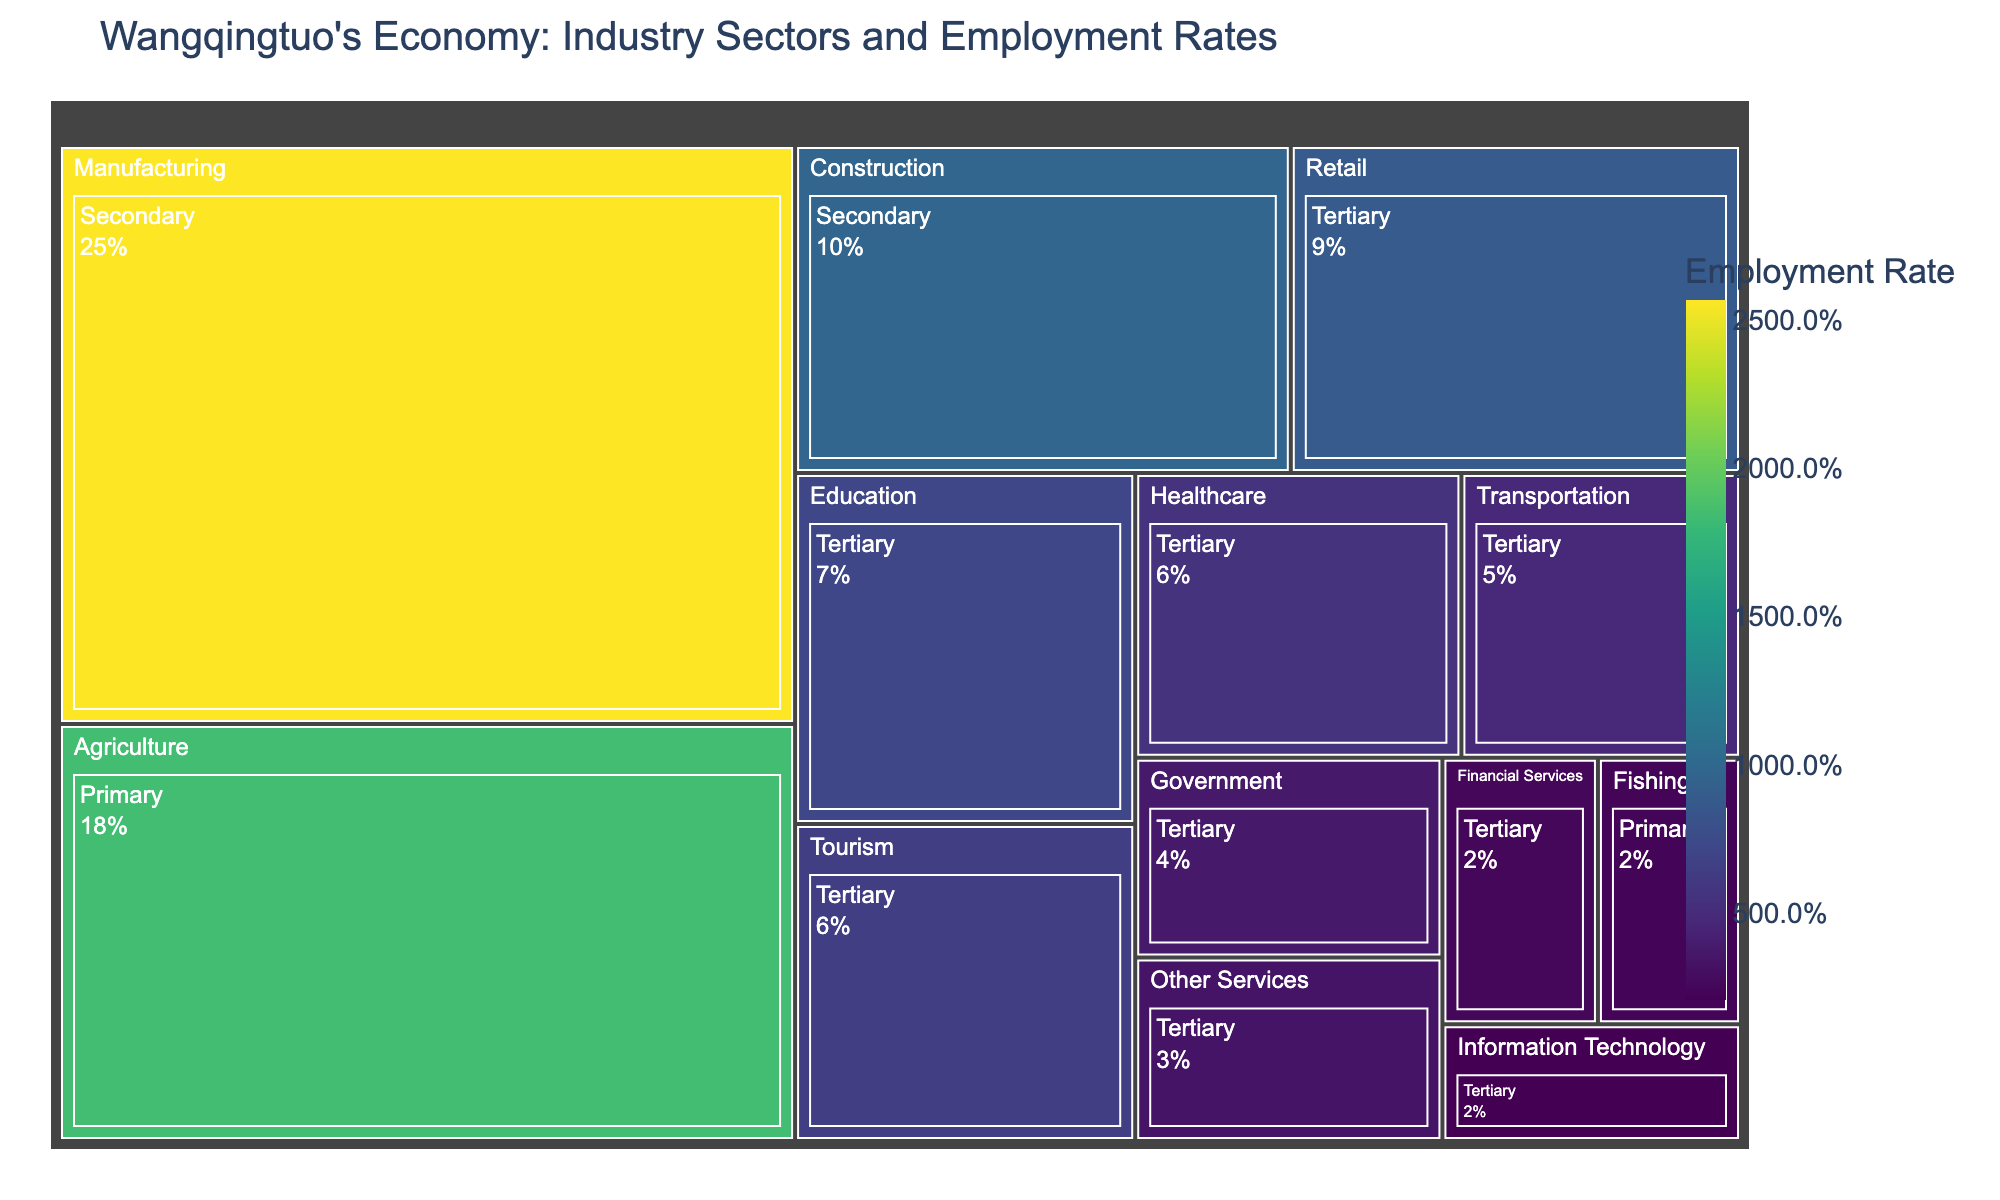What is the title of the Treemap? The title is usually located at the top of the figure and provides an overview of what the Treemap is displaying. In this case, it should indicate something about Wangqingtuo's economy in terms of industry sectors and employment rates.
Answer: Wangqingtuo's Economy: Industry Sectors and Employment Rates Which industry sector has the highest employment rate? By looking at the relative sizes of the sectors in the Treemap, the largest block corresponds to the sector with the highest employment rate.
Answer: Manufacturing How much higher is the employment rate in the Manufacturing sector compared to the Education sector? First, locate the employment rates in both sectors from the Treemap. Manufacturing has an employment rate of 25.7% and Education has 7.2%. The difference is calculated as 25.7 - 7.2.
Answer: 18.5% List all the industry sectors within the Primary category. In the Treemap, the sectors are usually grouped together. Look for the sectors labeled under Primary category.
Answer: Agriculture, Fishing What is the total employment rate for the Tertiary sector? Sum the employment rates of all the sub-sectors under Tertiary. The rates are: 7.2 (Education), 6.5 (Tourism), 8.9 (Retail), 5.6 (Healthcare), 4.8 (Transportation), 3.7 (Government), 2.5 (Financial Services), 2.1 (Information Technology), and 3.4 (Other Services). The total is 7.2+6.5+8.9+5.6+4.8+3.7+2.5+2.1+3.4.
Answer: 44.7% How does the employment rate in Agriculture compare to that in Healthcare? Locate the employment rates in both sectors from the Treemap. Agriculture has an employment rate of 18.5%, while Healthcare has 5.6%. Compare these values.
Answer: Agriculture has a higher employment rate Which sector within the Tertiary industry has the lowest employment rate, and what is it? Within the Tertiary sector, look for the smallest block or the one with the least percentage. The smallest block is Information Technology with an employment rate of 2.1%.
Answer: Information Technology, 2.1% What percentage of the Secondary sector does Construction represent? Within the Secondary sector, locate the blocks for Construction and Manufacturing, and find their employment rates. The total for the Secondary sector is 25.7 + 9.8. Construction represents 9.8 / (25.7 + 9.8) of the Secondary sector. Calculate 9.8 / 35.5 and multiply by 100.
Answer: 27.6% Which sector has a higher employment rate: Tourism or Government? Locate the employment rates for Tourism (6.5%) and Government (3.7%) from the Treemap and compare them. Tourism has a higher employment rate.
Answer: Tourism 